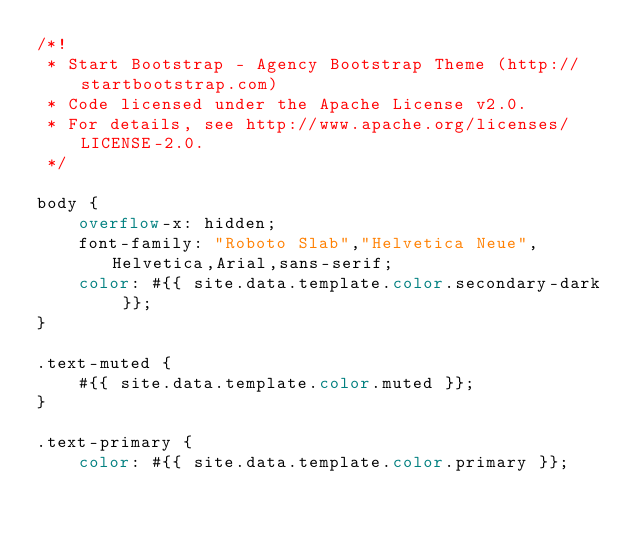Convert code to text. <code><loc_0><loc_0><loc_500><loc_500><_CSS_>/*!
 * Start Bootstrap - Agency Bootstrap Theme (http://startbootstrap.com)
 * Code licensed under the Apache License v2.0.
 * For details, see http://www.apache.org/licenses/LICENSE-2.0.
 */

body {
    overflow-x: hidden;
    font-family: "Roboto Slab","Helvetica Neue",Helvetica,Arial,sans-serif;
    color: #{{ site.data.template.color.secondary-dark }};
}

.text-muted {
    #{{ site.data.template.color.muted }};
}

.text-primary {
    color: #{{ site.data.template.color.primary }};</code> 